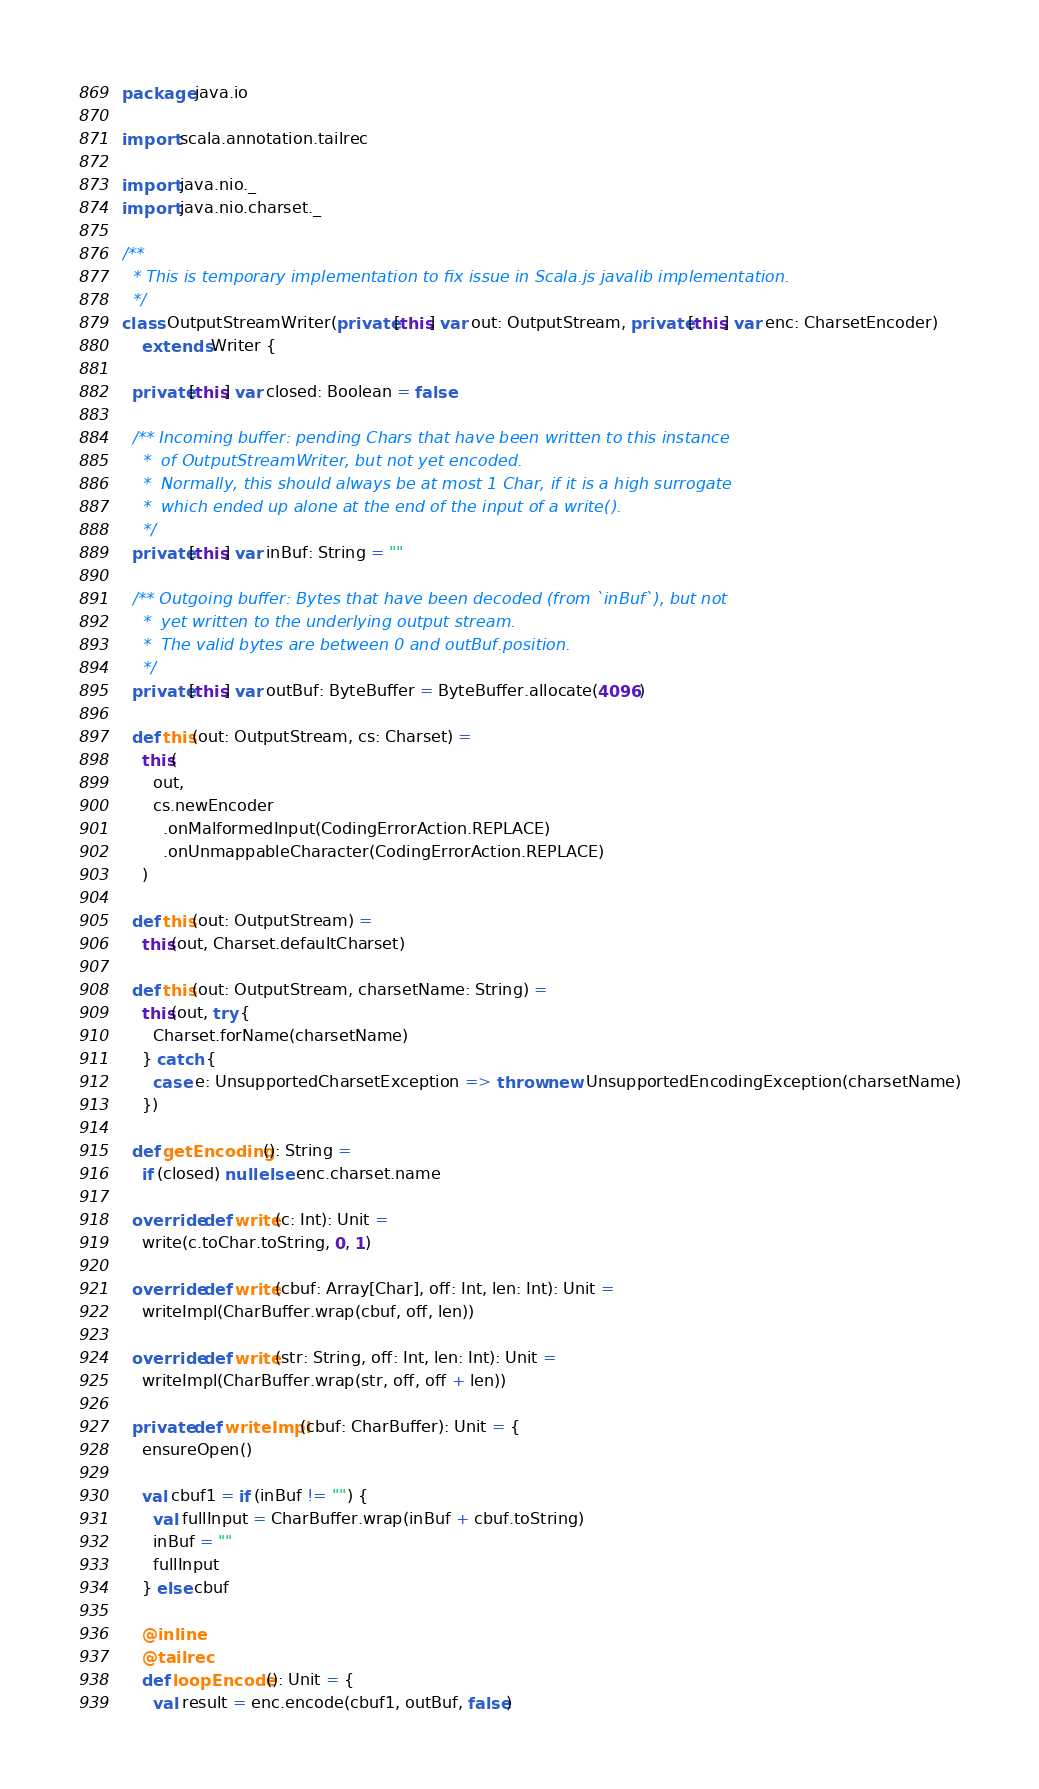Convert code to text. <code><loc_0><loc_0><loc_500><loc_500><_Scala_>package java.io

import scala.annotation.tailrec

import java.nio._
import java.nio.charset._

/**
  * This is temporary implementation to fix issue in Scala.js javalib implementation.
  */
class OutputStreamWriter(private[this] var out: OutputStream, private[this] var enc: CharsetEncoder)
    extends Writer {

  private[this] var closed: Boolean = false

  /** Incoming buffer: pending Chars that have been written to this instance
    *  of OutputStreamWriter, but not yet encoded.
    *  Normally, this should always be at most 1 Char, if it is a high surrogate
    *  which ended up alone at the end of the input of a write().
    */
  private[this] var inBuf: String = ""

  /** Outgoing buffer: Bytes that have been decoded (from `inBuf`), but not
    *  yet written to the underlying output stream.
    *  The valid bytes are between 0 and outBuf.position.
    */
  private[this] var outBuf: ByteBuffer = ByteBuffer.allocate(4096)

  def this(out: OutputStream, cs: Charset) =
    this(
      out,
      cs.newEncoder
        .onMalformedInput(CodingErrorAction.REPLACE)
        .onUnmappableCharacter(CodingErrorAction.REPLACE)
    )

  def this(out: OutputStream) =
    this(out, Charset.defaultCharset)

  def this(out: OutputStream, charsetName: String) =
    this(out, try {
      Charset.forName(charsetName)
    } catch {
      case e: UnsupportedCharsetException => throw new UnsupportedEncodingException(charsetName)
    })

  def getEncoding(): String =
    if (closed) null else enc.charset.name

  override def write(c: Int): Unit =
    write(c.toChar.toString, 0, 1)

  override def write(cbuf: Array[Char], off: Int, len: Int): Unit =
    writeImpl(CharBuffer.wrap(cbuf, off, len))

  override def write(str: String, off: Int, len: Int): Unit =
    writeImpl(CharBuffer.wrap(str, off, off + len))

  private def writeImpl(cbuf: CharBuffer): Unit = {
    ensureOpen()

    val cbuf1 = if (inBuf != "") {
      val fullInput = CharBuffer.wrap(inBuf + cbuf.toString)
      inBuf = ""
      fullInput
    } else cbuf

    @inline
    @tailrec
    def loopEncode(): Unit = {
      val result = enc.encode(cbuf1, outBuf, false)</code> 